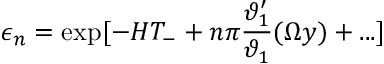<formula> <loc_0><loc_0><loc_500><loc_500>\epsilon _ { n } = \exp [ - H T _ { - } + n \pi \frac { \vartheta _ { 1 } ^ { \prime } } { \vartheta _ { 1 } } ( \Omega y ) + \dots ]</formula> 